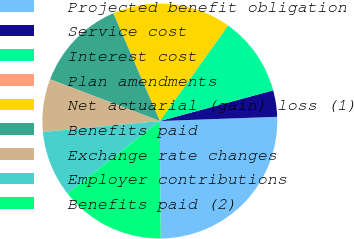Convert chart to OTSL. <chart><loc_0><loc_0><loc_500><loc_500><pie_chart><fcel>Projected benefit obligation<fcel>Service cost<fcel>Interest cost<fcel>Plan amendments<fcel>Net actuarial (gain) loss (1)<fcel>Benefits paid<fcel>Exchange rate changes<fcel>Employer contributions<fcel>Benefits paid (2)<nl><fcel>25.45%<fcel>3.64%<fcel>10.91%<fcel>0.0%<fcel>16.36%<fcel>12.73%<fcel>7.27%<fcel>9.09%<fcel>14.54%<nl></chart> 